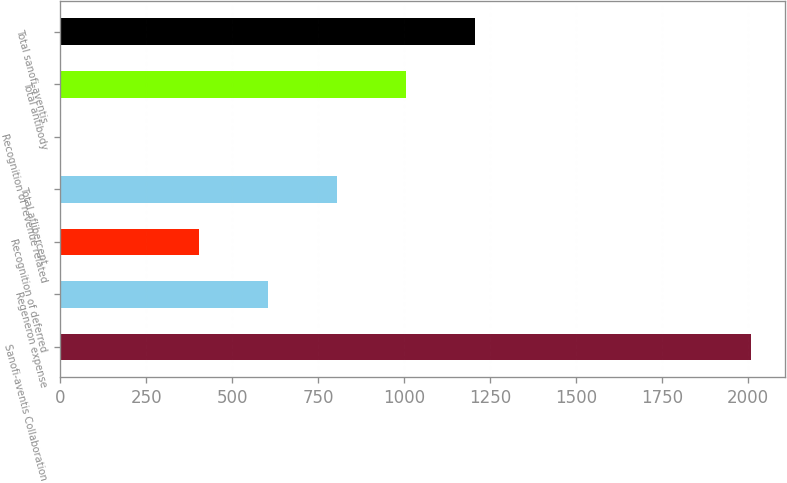Convert chart to OTSL. <chart><loc_0><loc_0><loc_500><loc_500><bar_chart><fcel>Sanofi-aventis Collaboration<fcel>Regeneron expense<fcel>Recognition of deferred<fcel>Total aflibercept<fcel>Recognition of revenue related<fcel>Total antibody<fcel>Total sanofi-aventis<nl><fcel>2008<fcel>603.24<fcel>402.56<fcel>803.92<fcel>1.2<fcel>1004.6<fcel>1205.28<nl></chart> 